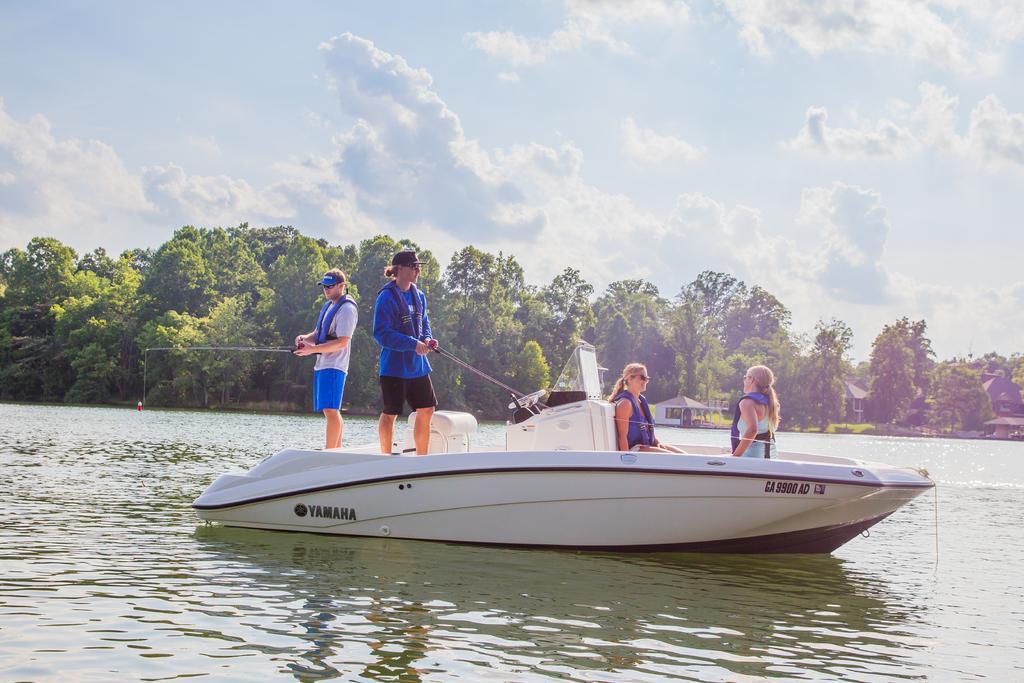Could you give a brief overview of what you see in this image? In this picture we can see there are two people sitting and two people standing on a boat and the boat is on the water. A person is holding a fishing equipment and the other person is holding an object. Behind the people there are trees, houses and a sky. 